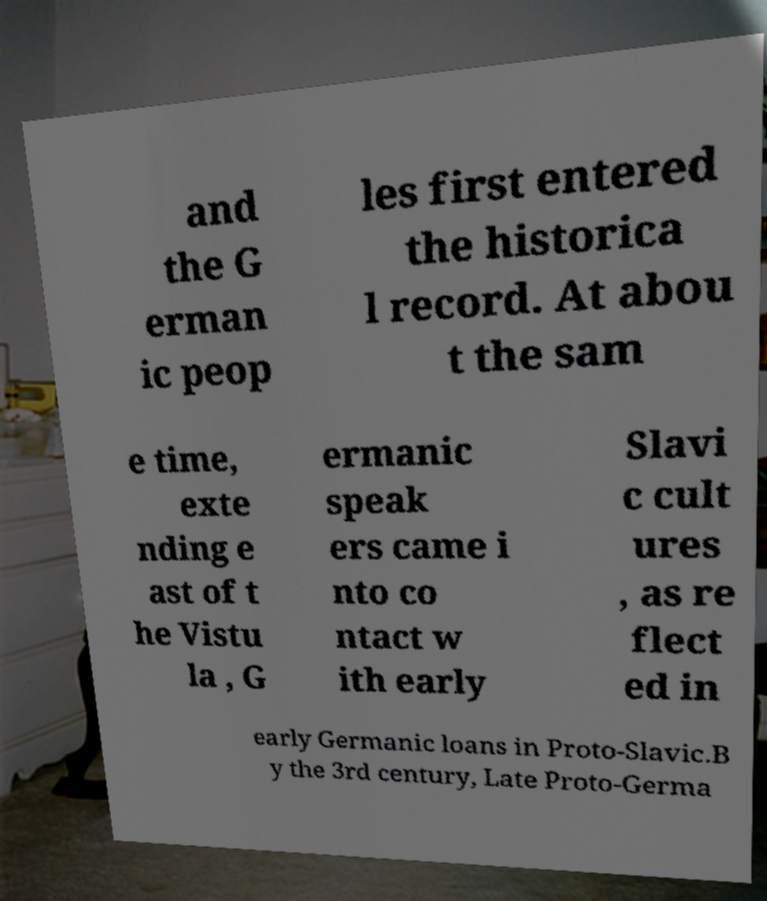For documentation purposes, I need the text within this image transcribed. Could you provide that? and the G erman ic peop les first entered the historica l record. At abou t the sam e time, exte nding e ast of t he Vistu la , G ermanic speak ers came i nto co ntact w ith early Slavi c cult ures , as re flect ed in early Germanic loans in Proto-Slavic.B y the 3rd century, Late Proto-Germa 